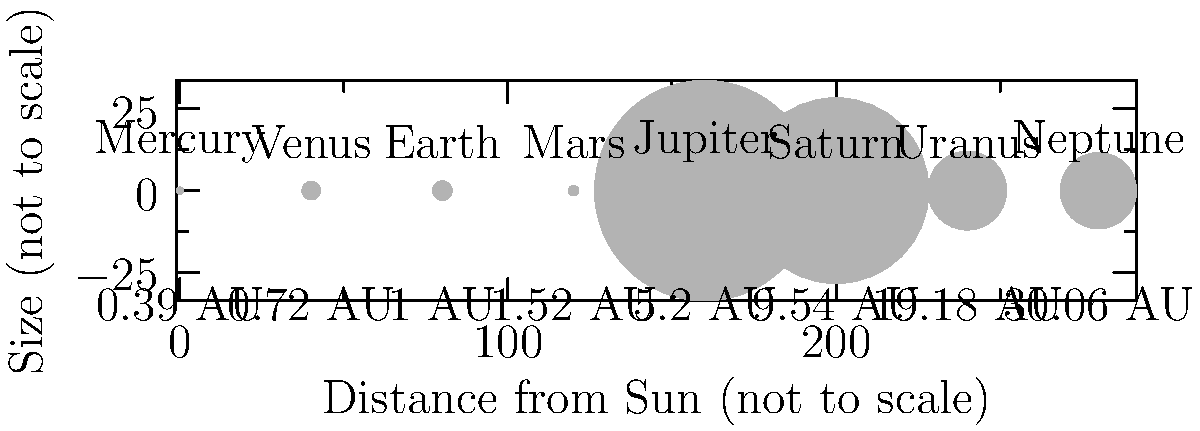As a television producer for race broadcasts, you're tasked with creating an educational segment comparing planets. Looking at the diagram of planet sizes and distances from the Sun, which planet would be most analogous to a "long-distance runner" in a cosmic race, considering both its size and distance from the Sun? To determine which planet is most analogous to a "long-distance runner" in a cosmic race, we need to consider both size and distance:

1. Analyze planet sizes:
   - Jupiter, Saturn, Uranus, and Neptune are significantly larger than the inner planets.
   - Earth is the largest of the inner planets, followed closely by Venus.

2. Examine distances from the Sun:
   - Mercury, Venus, Earth, and Mars are relatively close to the Sun.
   - Jupiter is the first of the outer planets, much farther out.
   - Saturn, Uranus, and Neptune are the most distant.

3. Consider the analogy of a "long-distance runner":
   - In races, long-distance runners are typically lean and efficient, not the largest competitors.
   - They need to cover great distances, so a planet far from the Sun fits this aspect.

4. Evaluate the options:
   - The giant planets (Jupiter, Saturn, Uranus, Neptune) are too large to be analogous to efficient runners.
   - The inner planets are too close to the Sun to represent "long-distance."
   - Mars stands out as relatively small (efficient) but significantly farther from the Sun than the other inner planets.

5. Conclusion:
   Mars best fits the analogy of a "long-distance runner" in this cosmic race scenario. It's relatively small (efficient) compared to the giant planets, yet it's positioned farther from the Sun than the other inner planets, representing the "long-distance" aspect.
Answer: Mars 